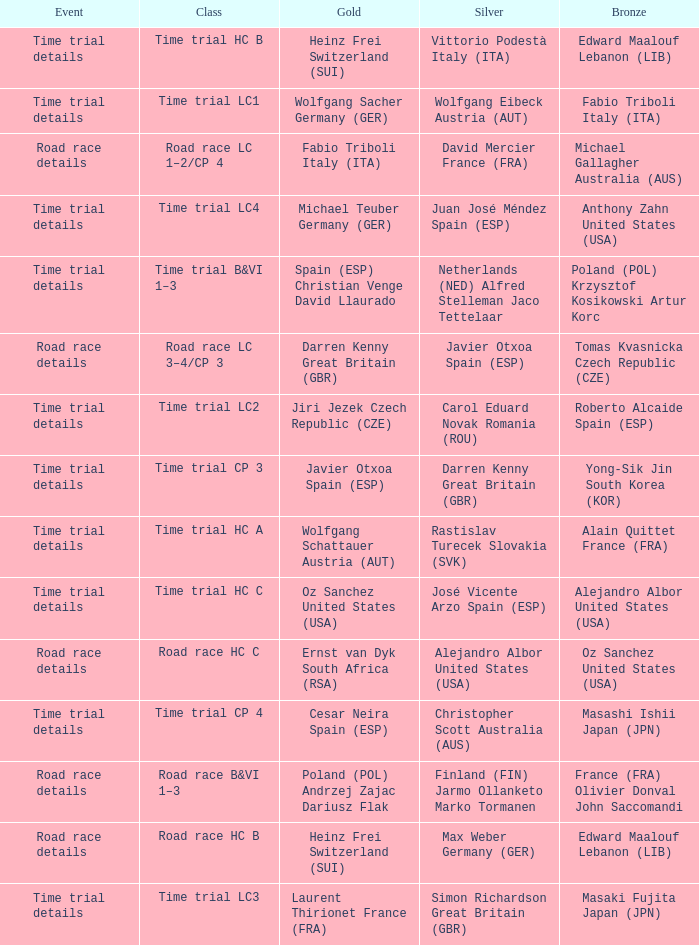What is the event when gold is darren kenny great britain (gbr)? Road race details. 